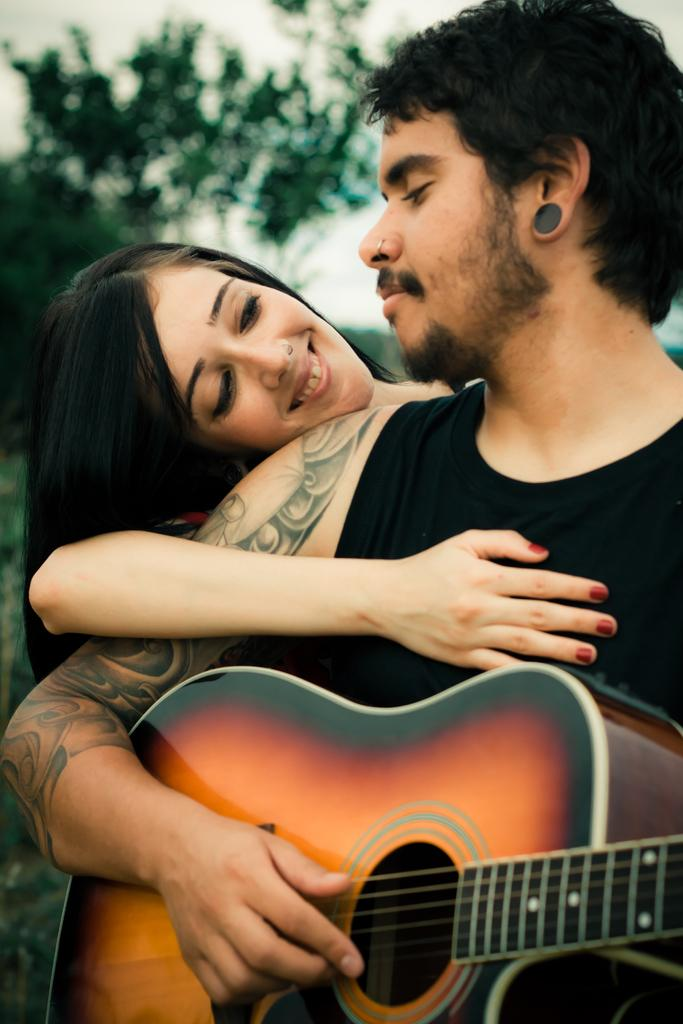What is the man in the image holding? The man is holding a guitar. Who else is present in the image? There is a woman in the image. What is the woman doing in the image? The woman is holding the man. What can be seen in the background of the image? There are trees visible in the background of the image. What scientific experiment is being conducted in the image? There is no scientific experiment present in the image. What type of exchange is taking place between the man and the woman in the image? There is no exchange taking place between the man and the woman in the image; the woman is simply holding the man. 